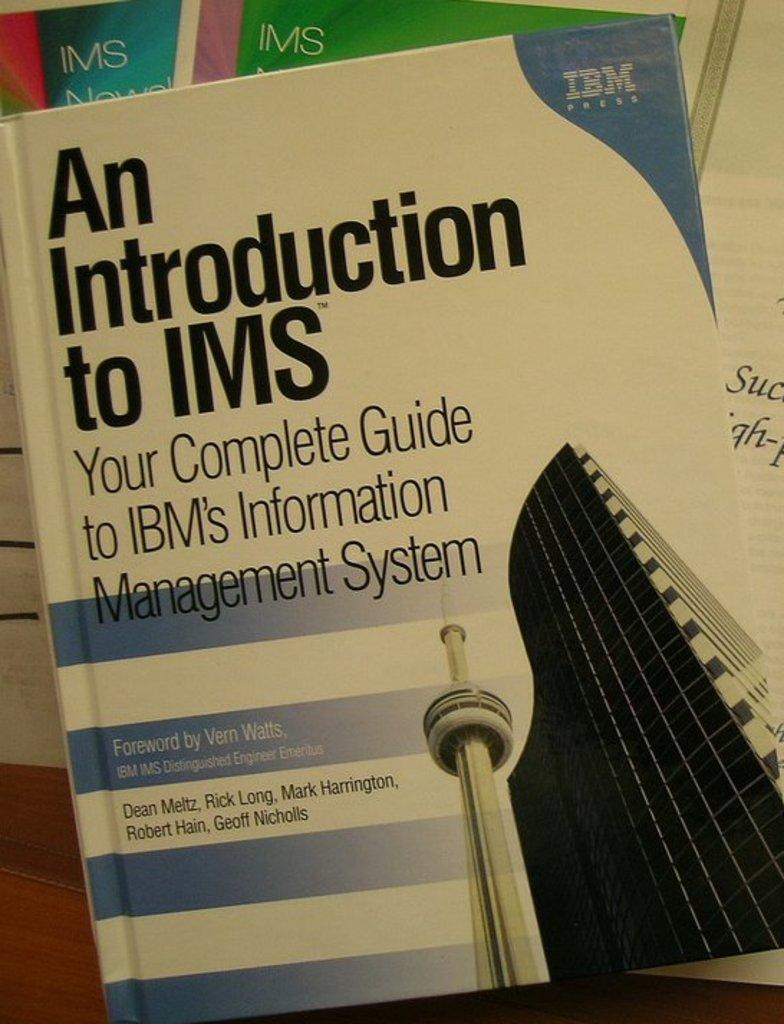Provide a one-sentence caption for the provided image. A white and blue book about a guide to IBM's Information Management System. 